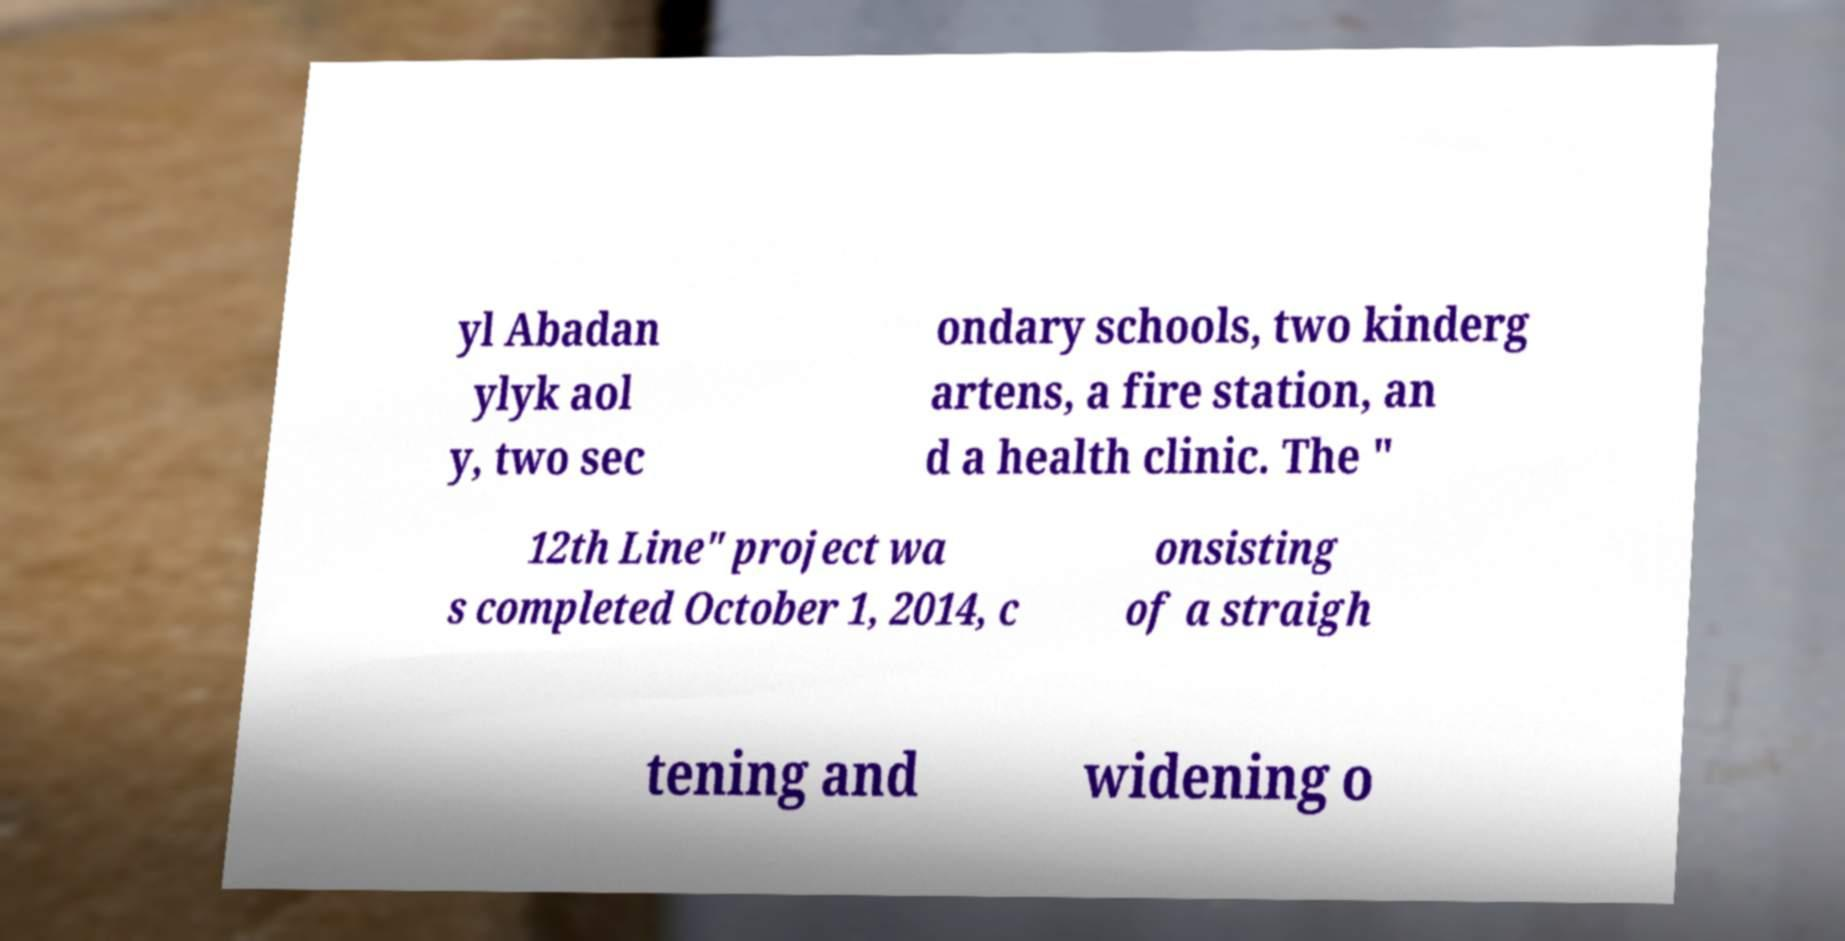Can you read and provide the text displayed in the image?This photo seems to have some interesting text. Can you extract and type it out for me? yl Abadan ylyk aol y, two sec ondary schools, two kinderg artens, a fire station, an d a health clinic. The " 12th Line" project wa s completed October 1, 2014, c onsisting of a straigh tening and widening o 